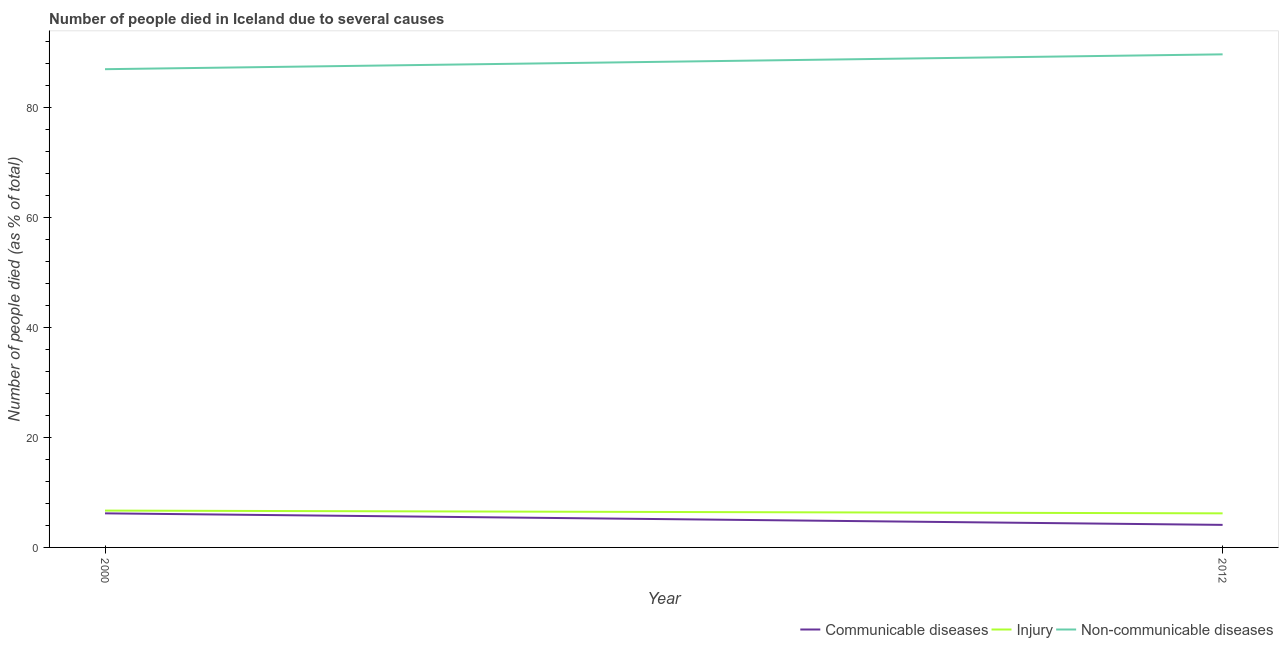How many different coloured lines are there?
Provide a short and direct response. 3. Is the number of lines equal to the number of legend labels?
Make the answer very short. Yes. What is the number of people who dies of non-communicable diseases in 2012?
Provide a short and direct response. 89.7. In which year was the number of people who dies of non-communicable diseases maximum?
Provide a short and direct response. 2012. In which year was the number of people who died of communicable diseases minimum?
Ensure brevity in your answer.  2012. What is the total number of people who died of injury in the graph?
Keep it short and to the point. 12.9. What is the difference between the number of people who dies of non-communicable diseases in 2012 and the number of people who died of communicable diseases in 2000?
Your response must be concise. 83.5. What is the average number of people who died of communicable diseases per year?
Your response must be concise. 5.15. In the year 2012, what is the difference between the number of people who dies of non-communicable diseases and number of people who died of injury?
Make the answer very short. 83.5. In how many years, is the number of people who died of communicable diseases greater than 24 %?
Your response must be concise. 0. What is the ratio of the number of people who died of communicable diseases in 2000 to that in 2012?
Make the answer very short. 1.51. Is it the case that in every year, the sum of the number of people who died of communicable diseases and number of people who died of injury is greater than the number of people who dies of non-communicable diseases?
Give a very brief answer. No. How many lines are there?
Your response must be concise. 3. How many years are there in the graph?
Your answer should be very brief. 2. Where does the legend appear in the graph?
Keep it short and to the point. Bottom right. How are the legend labels stacked?
Your answer should be very brief. Horizontal. What is the title of the graph?
Make the answer very short. Number of people died in Iceland due to several causes. What is the label or title of the Y-axis?
Offer a very short reply. Number of people died (as % of total). What is the Number of people died (as % of total) in Injury in 2000?
Provide a succinct answer. 6.7. What is the Number of people died (as % of total) of Non-communicable diseases in 2000?
Offer a terse response. 87. What is the Number of people died (as % of total) in Communicable diseases in 2012?
Keep it short and to the point. 4.1. What is the Number of people died (as % of total) of Non-communicable diseases in 2012?
Offer a very short reply. 89.7. Across all years, what is the maximum Number of people died (as % of total) in Communicable diseases?
Provide a short and direct response. 6.2. Across all years, what is the maximum Number of people died (as % of total) of Injury?
Ensure brevity in your answer.  6.7. Across all years, what is the maximum Number of people died (as % of total) in Non-communicable diseases?
Provide a short and direct response. 89.7. Across all years, what is the minimum Number of people died (as % of total) of Communicable diseases?
Give a very brief answer. 4.1. Across all years, what is the minimum Number of people died (as % of total) of Injury?
Make the answer very short. 6.2. What is the total Number of people died (as % of total) in Injury in the graph?
Your answer should be compact. 12.9. What is the total Number of people died (as % of total) in Non-communicable diseases in the graph?
Ensure brevity in your answer.  176.7. What is the difference between the Number of people died (as % of total) in Injury in 2000 and that in 2012?
Provide a succinct answer. 0.5. What is the difference between the Number of people died (as % of total) in Communicable diseases in 2000 and the Number of people died (as % of total) in Non-communicable diseases in 2012?
Provide a short and direct response. -83.5. What is the difference between the Number of people died (as % of total) of Injury in 2000 and the Number of people died (as % of total) of Non-communicable diseases in 2012?
Provide a short and direct response. -83. What is the average Number of people died (as % of total) in Communicable diseases per year?
Offer a terse response. 5.15. What is the average Number of people died (as % of total) of Injury per year?
Provide a succinct answer. 6.45. What is the average Number of people died (as % of total) of Non-communicable diseases per year?
Offer a very short reply. 88.35. In the year 2000, what is the difference between the Number of people died (as % of total) of Communicable diseases and Number of people died (as % of total) of Injury?
Your answer should be very brief. -0.5. In the year 2000, what is the difference between the Number of people died (as % of total) of Communicable diseases and Number of people died (as % of total) of Non-communicable diseases?
Provide a short and direct response. -80.8. In the year 2000, what is the difference between the Number of people died (as % of total) in Injury and Number of people died (as % of total) in Non-communicable diseases?
Provide a short and direct response. -80.3. In the year 2012, what is the difference between the Number of people died (as % of total) of Communicable diseases and Number of people died (as % of total) of Injury?
Your answer should be compact. -2.1. In the year 2012, what is the difference between the Number of people died (as % of total) of Communicable diseases and Number of people died (as % of total) of Non-communicable diseases?
Your answer should be compact. -85.6. In the year 2012, what is the difference between the Number of people died (as % of total) of Injury and Number of people died (as % of total) of Non-communicable diseases?
Provide a succinct answer. -83.5. What is the ratio of the Number of people died (as % of total) of Communicable diseases in 2000 to that in 2012?
Offer a terse response. 1.51. What is the ratio of the Number of people died (as % of total) in Injury in 2000 to that in 2012?
Ensure brevity in your answer.  1.08. What is the ratio of the Number of people died (as % of total) in Non-communicable diseases in 2000 to that in 2012?
Keep it short and to the point. 0.97. What is the difference between the highest and the second highest Number of people died (as % of total) in Communicable diseases?
Your answer should be compact. 2.1. 